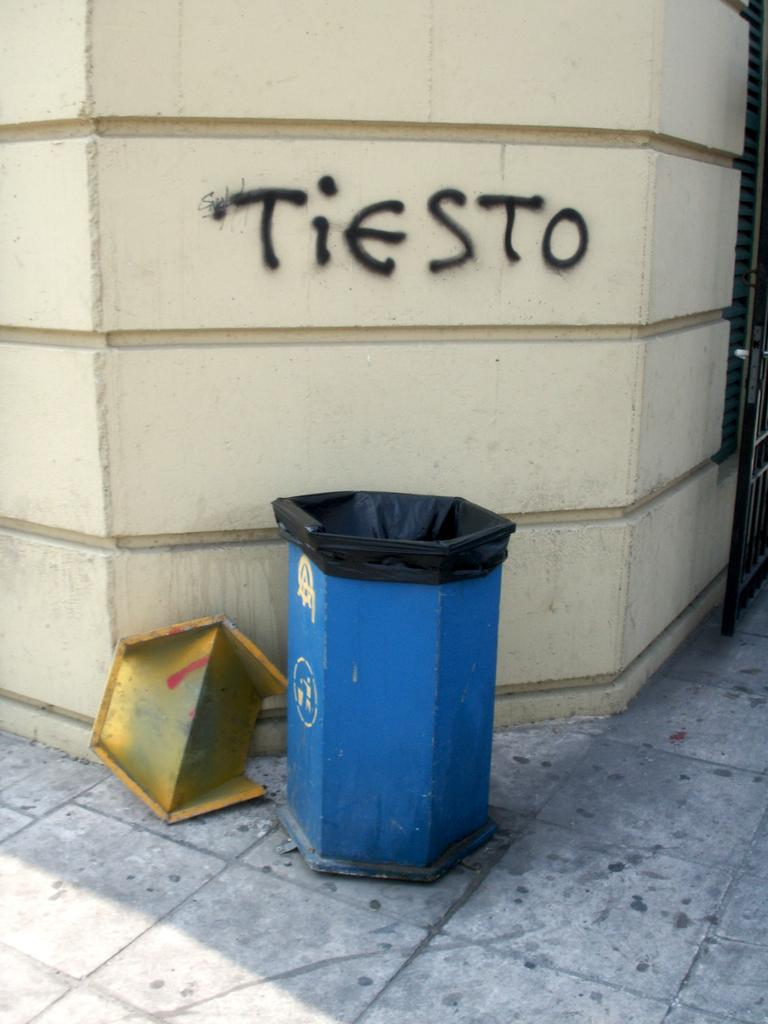Provide a one-sentence caption for the provided image. The word Tiesto is spray painted on a wall above a garbage can line with black plastic. 